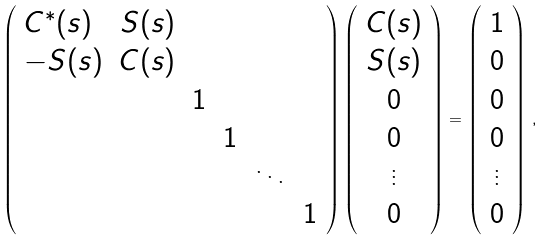<formula> <loc_0><loc_0><loc_500><loc_500>\left ( \begin{array} { l r c c c c } C ^ { * } ( s ) & S ( s ) & & & & \\ - S ( s ) & C ( s ) & & & & \\ & & 1 & & & \\ & & & 1 & & \\ & & & & \ddots & \\ & & & & & 1 \end{array} \right ) \left ( \begin{array} { c } C ( s ) \\ S ( s ) \\ 0 \\ 0 \\ \vdots \\ 0 \end{array} \right ) = \left ( \begin{array} { c } 1 \\ 0 \\ 0 \\ 0 \\ \vdots \\ 0 \end{array} \right ) \, ,</formula> 